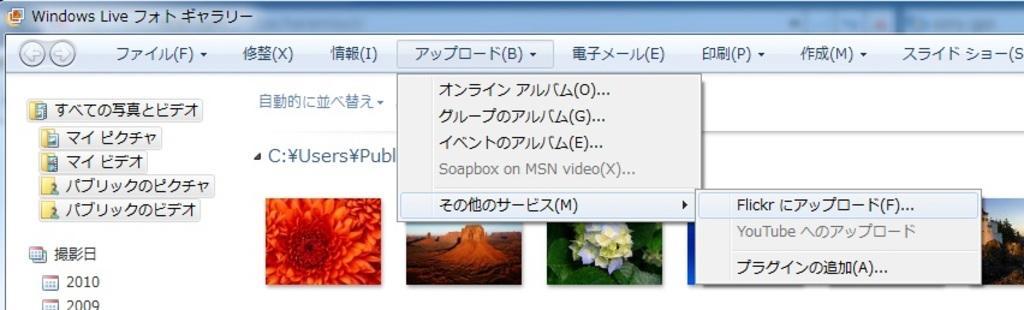Can you describe this image briefly? It is the screenshot image of a desktop screen. In the image we can see that there are some wall papers in the middle and there is some text above it. 